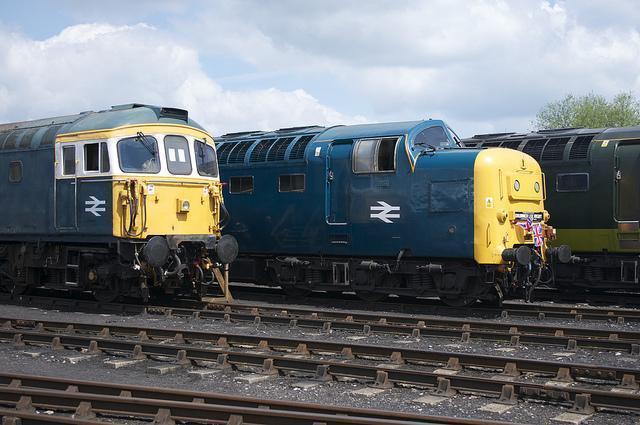The front of the vehicle is mostly the color of what?
Choose the correct response and explain in the format: 'Answer: answer
Rationale: rationale.'
Options: Cherry, tangerine, lime, mustard. Answer: mustard.
Rationale: The front of the vehicle is yellow, not orange, red, or green. 